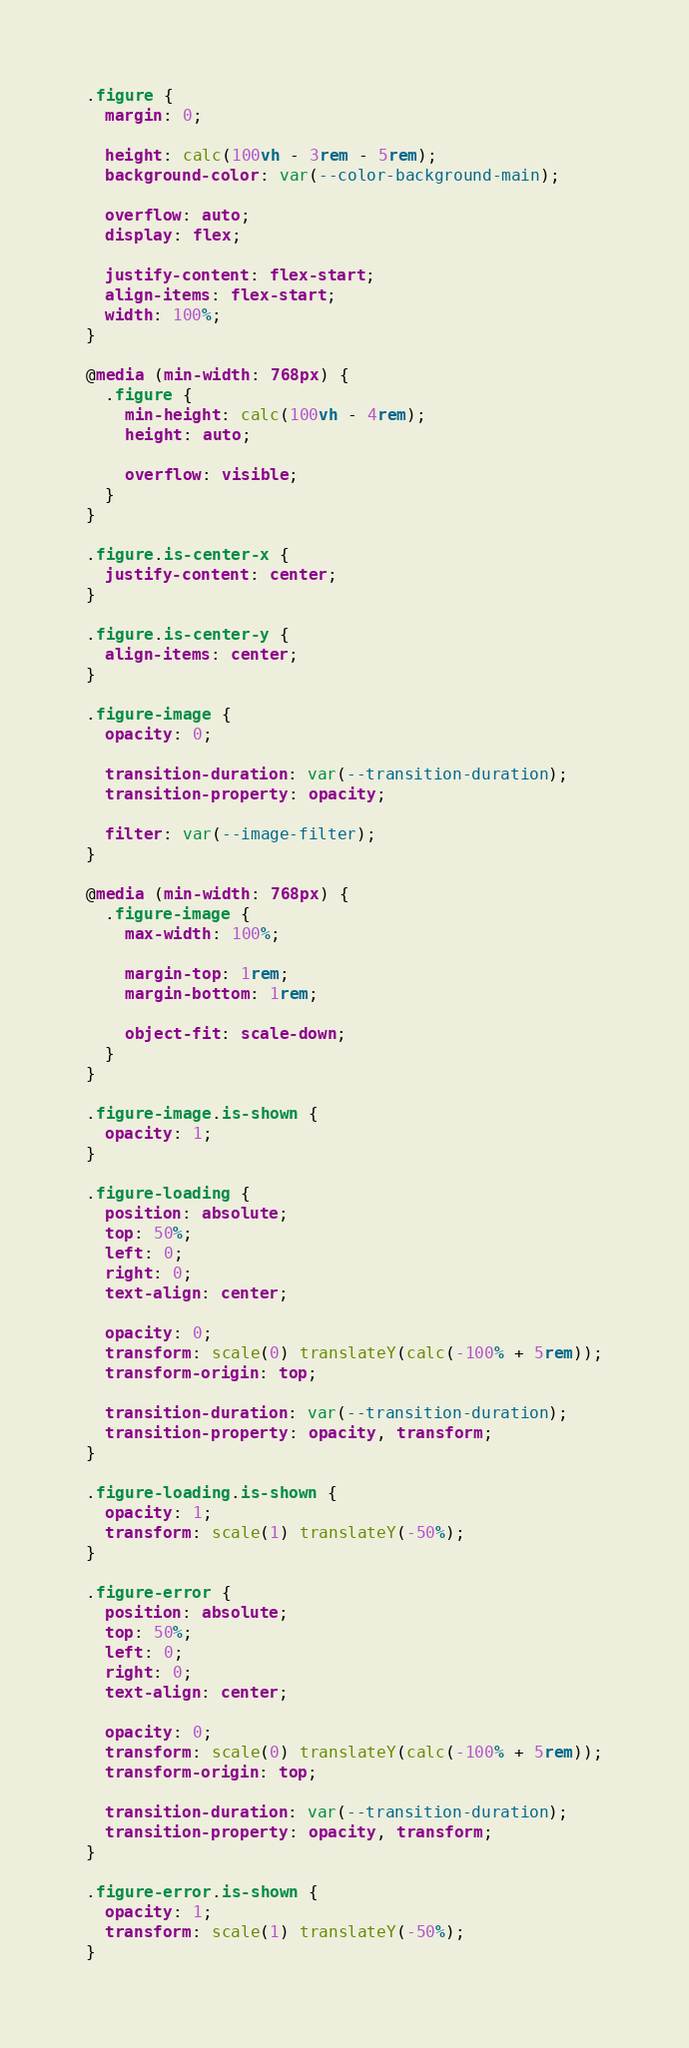Convert code to text. <code><loc_0><loc_0><loc_500><loc_500><_CSS_>.figure {
  margin: 0;

  height: calc(100vh - 3rem - 5rem);
  background-color: var(--color-background-main);

  overflow: auto;
  display: flex;

  justify-content: flex-start;
  align-items: flex-start;
  width: 100%;
}

@media (min-width: 768px) {
  .figure {
    min-height: calc(100vh - 4rem);
    height: auto;

    overflow: visible;
  }
}

.figure.is-center-x {
  justify-content: center;
}

.figure.is-center-y {
  align-items: center;
}

.figure-image {
  opacity: 0;

  transition-duration: var(--transition-duration);
  transition-property: opacity;

  filter: var(--image-filter);
}

@media (min-width: 768px) {
  .figure-image {
    max-width: 100%;

    margin-top: 1rem;
    margin-bottom: 1rem;

    object-fit: scale-down;
  }
}

.figure-image.is-shown {
  opacity: 1;
}

.figure-loading {
  position: absolute;
  top: 50%;
  left: 0;
  right: 0;
  text-align: center;

  opacity: 0;
  transform: scale(0) translateY(calc(-100% + 5rem));
  transform-origin: top;

  transition-duration: var(--transition-duration);
  transition-property: opacity, transform;
}

.figure-loading.is-shown {
  opacity: 1;
  transform: scale(1) translateY(-50%);
}

.figure-error {
  position: absolute;
  top: 50%;
  left: 0;
  right: 0;
  text-align: center;

  opacity: 0;
  transform: scale(0) translateY(calc(-100% + 5rem));
  transform-origin: top;

  transition-duration: var(--transition-duration);
  transition-property: opacity, transform;
}

.figure-error.is-shown {
  opacity: 1;
  transform: scale(1) translateY(-50%);
}
</code> 